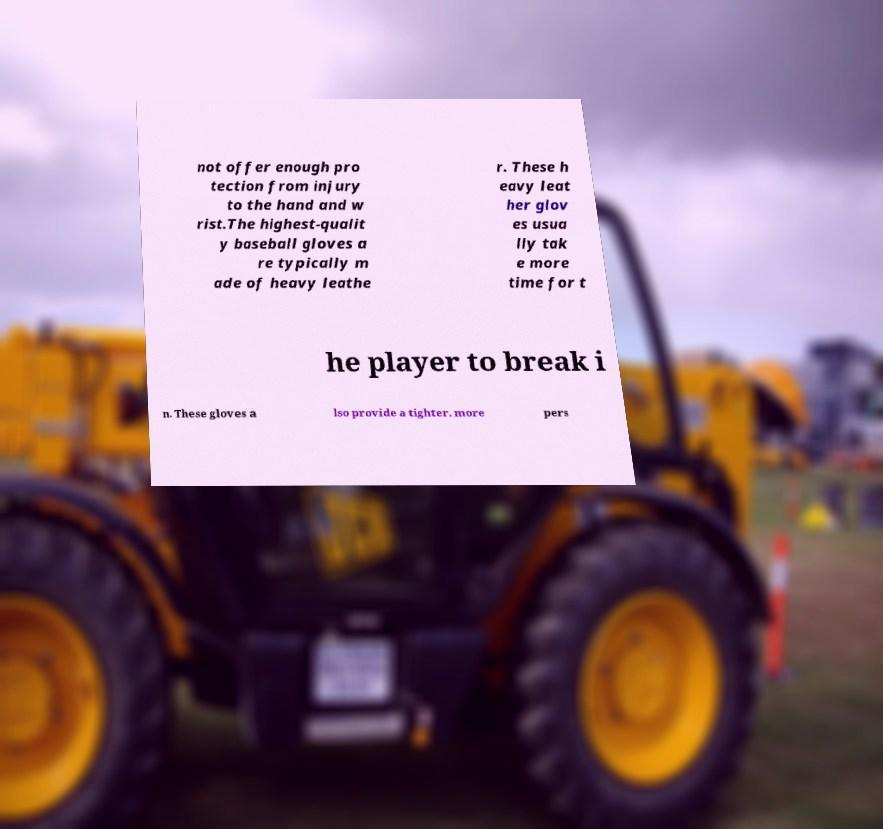Can you accurately transcribe the text from the provided image for me? not offer enough pro tection from injury to the hand and w rist.The highest-qualit y baseball gloves a re typically m ade of heavy leathe r. These h eavy leat her glov es usua lly tak e more time for t he player to break i n. These gloves a lso provide a tighter, more pers 